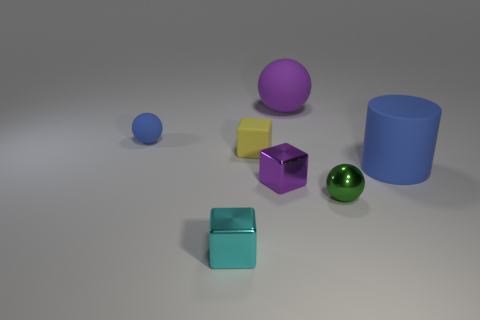Add 1 tiny gray blocks. How many objects exist? 8 Subtract all blocks. How many objects are left? 4 Subtract all tiny green shiny things. Subtract all big cyan blocks. How many objects are left? 6 Add 1 big purple spheres. How many big purple spheres are left? 2 Add 7 balls. How many balls exist? 10 Subtract 1 blue balls. How many objects are left? 6 